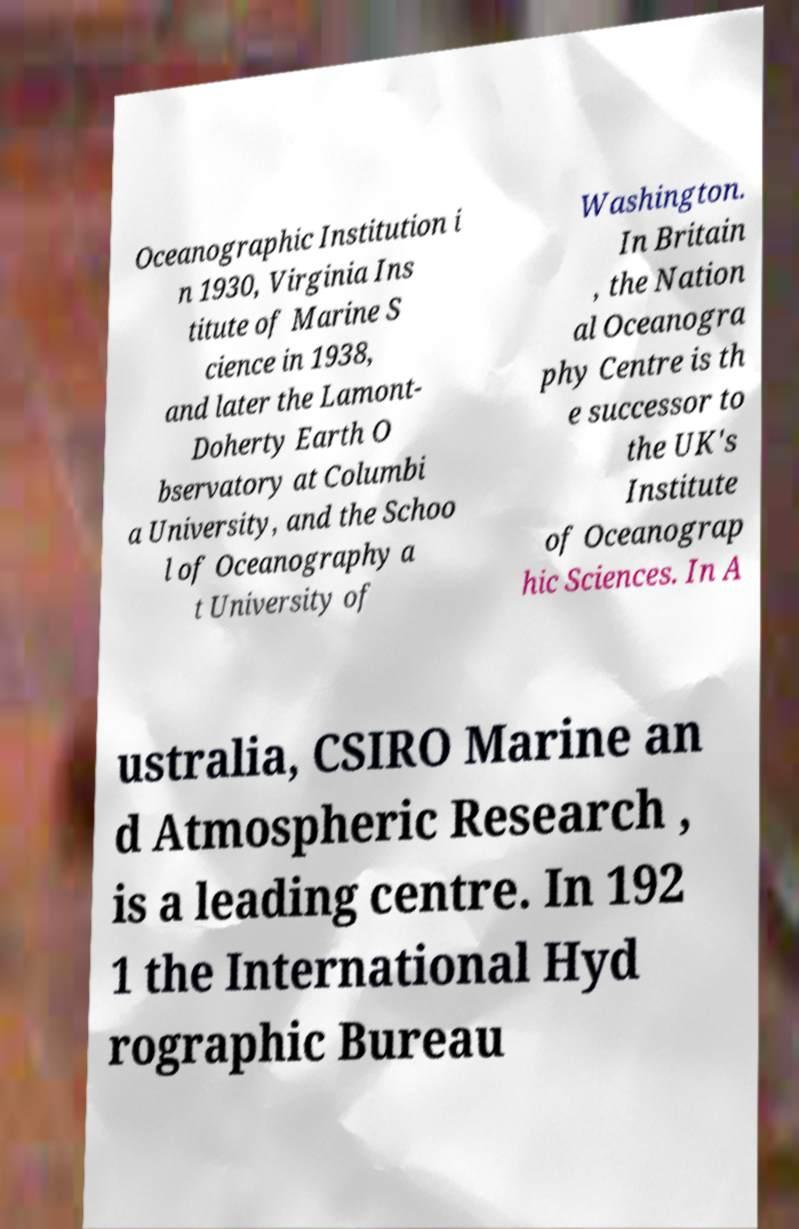For documentation purposes, I need the text within this image transcribed. Could you provide that? Oceanographic Institution i n 1930, Virginia Ins titute of Marine S cience in 1938, and later the Lamont- Doherty Earth O bservatory at Columbi a University, and the Schoo l of Oceanography a t University of Washington. In Britain , the Nation al Oceanogra phy Centre is th e successor to the UK's Institute of Oceanograp hic Sciences. In A ustralia, CSIRO Marine an d Atmospheric Research , is a leading centre. In 192 1 the International Hyd rographic Bureau 